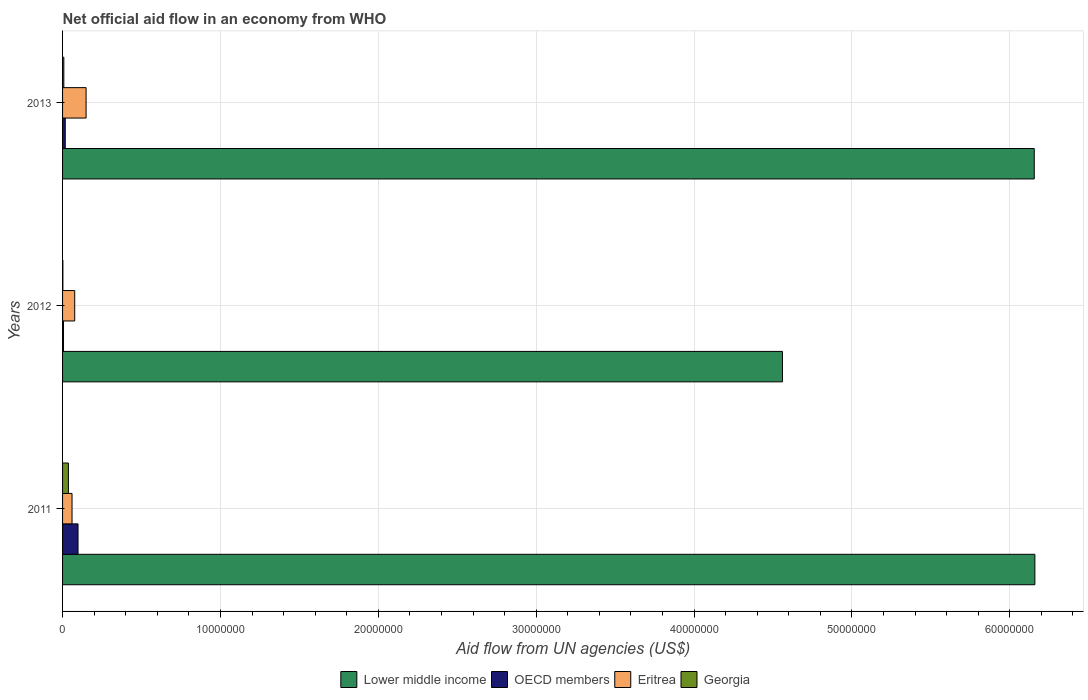How many groups of bars are there?
Give a very brief answer. 3. Are the number of bars per tick equal to the number of legend labels?
Keep it short and to the point. Yes. What is the net official aid flow in Georgia in 2013?
Give a very brief answer. 8.00e+04. Across all years, what is the maximum net official aid flow in Eritrea?
Provide a short and direct response. 1.49e+06. Across all years, what is the minimum net official aid flow in Georgia?
Provide a succinct answer. 2.00e+04. In which year was the net official aid flow in Lower middle income maximum?
Give a very brief answer. 2011. In which year was the net official aid flow in Georgia minimum?
Provide a short and direct response. 2012. What is the total net official aid flow in Georgia in the graph?
Offer a terse response. 4.70e+05. What is the difference between the net official aid flow in OECD members in 2012 and that in 2013?
Provide a short and direct response. -1.10e+05. What is the difference between the net official aid flow in Georgia in 2013 and the net official aid flow in Eritrea in 2012?
Your answer should be very brief. -6.90e+05. What is the average net official aid flow in Lower middle income per year?
Your response must be concise. 5.62e+07. In the year 2011, what is the difference between the net official aid flow in Georgia and net official aid flow in Lower middle income?
Provide a short and direct response. -6.12e+07. In how many years, is the net official aid flow in OECD members greater than 12000000 US$?
Offer a terse response. 0. What is the ratio of the net official aid flow in OECD members in 2012 to that in 2013?
Give a very brief answer. 0.35. What is the difference between the highest and the second highest net official aid flow in Eritrea?
Your answer should be very brief. 7.20e+05. What is the difference between the highest and the lowest net official aid flow in Lower middle income?
Your answer should be compact. 1.60e+07. Is the sum of the net official aid flow in Lower middle income in 2011 and 2012 greater than the maximum net official aid flow in OECD members across all years?
Your answer should be very brief. Yes. Is it the case that in every year, the sum of the net official aid flow in OECD members and net official aid flow in Lower middle income is greater than the sum of net official aid flow in Eritrea and net official aid flow in Georgia?
Your answer should be compact. No. What does the 1st bar from the top in 2012 represents?
Make the answer very short. Georgia. What does the 1st bar from the bottom in 2013 represents?
Offer a terse response. Lower middle income. Is it the case that in every year, the sum of the net official aid flow in OECD members and net official aid flow in Georgia is greater than the net official aid flow in Eritrea?
Offer a very short reply. No. Are all the bars in the graph horizontal?
Your response must be concise. Yes. How many years are there in the graph?
Provide a succinct answer. 3. Does the graph contain any zero values?
Your answer should be compact. No. Where does the legend appear in the graph?
Ensure brevity in your answer.  Bottom center. How many legend labels are there?
Your response must be concise. 4. How are the legend labels stacked?
Make the answer very short. Horizontal. What is the title of the graph?
Your answer should be very brief. Net official aid flow in an economy from WHO. What is the label or title of the X-axis?
Offer a terse response. Aid flow from UN agencies (US$). What is the label or title of the Y-axis?
Offer a terse response. Years. What is the Aid flow from UN agencies (US$) in Lower middle income in 2011?
Your answer should be compact. 6.16e+07. What is the Aid flow from UN agencies (US$) in OECD members in 2011?
Offer a terse response. 9.80e+05. What is the Aid flow from UN agencies (US$) of Georgia in 2011?
Your answer should be very brief. 3.70e+05. What is the Aid flow from UN agencies (US$) in Lower middle income in 2012?
Give a very brief answer. 4.56e+07. What is the Aid flow from UN agencies (US$) in Eritrea in 2012?
Your answer should be very brief. 7.70e+05. What is the Aid flow from UN agencies (US$) of Lower middle income in 2013?
Keep it short and to the point. 6.16e+07. What is the Aid flow from UN agencies (US$) of OECD members in 2013?
Your answer should be compact. 1.70e+05. What is the Aid flow from UN agencies (US$) in Eritrea in 2013?
Your response must be concise. 1.49e+06. Across all years, what is the maximum Aid flow from UN agencies (US$) of Lower middle income?
Your answer should be very brief. 6.16e+07. Across all years, what is the maximum Aid flow from UN agencies (US$) of OECD members?
Your response must be concise. 9.80e+05. Across all years, what is the maximum Aid flow from UN agencies (US$) in Eritrea?
Give a very brief answer. 1.49e+06. Across all years, what is the maximum Aid flow from UN agencies (US$) of Georgia?
Your response must be concise. 3.70e+05. Across all years, what is the minimum Aid flow from UN agencies (US$) of Lower middle income?
Your answer should be compact. 4.56e+07. Across all years, what is the minimum Aid flow from UN agencies (US$) of Eritrea?
Provide a succinct answer. 6.00e+05. Across all years, what is the minimum Aid flow from UN agencies (US$) in Georgia?
Offer a very short reply. 2.00e+04. What is the total Aid flow from UN agencies (US$) in Lower middle income in the graph?
Provide a succinct answer. 1.69e+08. What is the total Aid flow from UN agencies (US$) of OECD members in the graph?
Offer a terse response. 1.21e+06. What is the total Aid flow from UN agencies (US$) in Eritrea in the graph?
Ensure brevity in your answer.  2.86e+06. What is the difference between the Aid flow from UN agencies (US$) in Lower middle income in 2011 and that in 2012?
Your answer should be very brief. 1.60e+07. What is the difference between the Aid flow from UN agencies (US$) of OECD members in 2011 and that in 2012?
Make the answer very short. 9.20e+05. What is the difference between the Aid flow from UN agencies (US$) of Eritrea in 2011 and that in 2012?
Offer a very short reply. -1.70e+05. What is the difference between the Aid flow from UN agencies (US$) of OECD members in 2011 and that in 2013?
Make the answer very short. 8.10e+05. What is the difference between the Aid flow from UN agencies (US$) in Eritrea in 2011 and that in 2013?
Your answer should be compact. -8.90e+05. What is the difference between the Aid flow from UN agencies (US$) in Georgia in 2011 and that in 2013?
Offer a very short reply. 2.90e+05. What is the difference between the Aid flow from UN agencies (US$) of Lower middle income in 2012 and that in 2013?
Make the answer very short. -1.60e+07. What is the difference between the Aid flow from UN agencies (US$) in OECD members in 2012 and that in 2013?
Ensure brevity in your answer.  -1.10e+05. What is the difference between the Aid flow from UN agencies (US$) of Eritrea in 2012 and that in 2013?
Provide a short and direct response. -7.20e+05. What is the difference between the Aid flow from UN agencies (US$) in Lower middle income in 2011 and the Aid flow from UN agencies (US$) in OECD members in 2012?
Offer a very short reply. 6.15e+07. What is the difference between the Aid flow from UN agencies (US$) in Lower middle income in 2011 and the Aid flow from UN agencies (US$) in Eritrea in 2012?
Offer a very short reply. 6.08e+07. What is the difference between the Aid flow from UN agencies (US$) in Lower middle income in 2011 and the Aid flow from UN agencies (US$) in Georgia in 2012?
Your response must be concise. 6.16e+07. What is the difference between the Aid flow from UN agencies (US$) in OECD members in 2011 and the Aid flow from UN agencies (US$) in Georgia in 2012?
Make the answer very short. 9.60e+05. What is the difference between the Aid flow from UN agencies (US$) of Eritrea in 2011 and the Aid flow from UN agencies (US$) of Georgia in 2012?
Provide a short and direct response. 5.80e+05. What is the difference between the Aid flow from UN agencies (US$) of Lower middle income in 2011 and the Aid flow from UN agencies (US$) of OECD members in 2013?
Keep it short and to the point. 6.14e+07. What is the difference between the Aid flow from UN agencies (US$) in Lower middle income in 2011 and the Aid flow from UN agencies (US$) in Eritrea in 2013?
Offer a very short reply. 6.01e+07. What is the difference between the Aid flow from UN agencies (US$) in Lower middle income in 2011 and the Aid flow from UN agencies (US$) in Georgia in 2013?
Provide a succinct answer. 6.15e+07. What is the difference between the Aid flow from UN agencies (US$) in OECD members in 2011 and the Aid flow from UN agencies (US$) in Eritrea in 2013?
Offer a terse response. -5.10e+05. What is the difference between the Aid flow from UN agencies (US$) in Eritrea in 2011 and the Aid flow from UN agencies (US$) in Georgia in 2013?
Offer a terse response. 5.20e+05. What is the difference between the Aid flow from UN agencies (US$) in Lower middle income in 2012 and the Aid flow from UN agencies (US$) in OECD members in 2013?
Offer a terse response. 4.54e+07. What is the difference between the Aid flow from UN agencies (US$) in Lower middle income in 2012 and the Aid flow from UN agencies (US$) in Eritrea in 2013?
Offer a terse response. 4.41e+07. What is the difference between the Aid flow from UN agencies (US$) of Lower middle income in 2012 and the Aid flow from UN agencies (US$) of Georgia in 2013?
Offer a terse response. 4.55e+07. What is the difference between the Aid flow from UN agencies (US$) of OECD members in 2012 and the Aid flow from UN agencies (US$) of Eritrea in 2013?
Make the answer very short. -1.43e+06. What is the difference between the Aid flow from UN agencies (US$) in OECD members in 2012 and the Aid flow from UN agencies (US$) in Georgia in 2013?
Provide a short and direct response. -2.00e+04. What is the difference between the Aid flow from UN agencies (US$) of Eritrea in 2012 and the Aid flow from UN agencies (US$) of Georgia in 2013?
Offer a terse response. 6.90e+05. What is the average Aid flow from UN agencies (US$) in Lower middle income per year?
Provide a succinct answer. 5.62e+07. What is the average Aid flow from UN agencies (US$) in OECD members per year?
Give a very brief answer. 4.03e+05. What is the average Aid flow from UN agencies (US$) of Eritrea per year?
Offer a very short reply. 9.53e+05. What is the average Aid flow from UN agencies (US$) of Georgia per year?
Give a very brief answer. 1.57e+05. In the year 2011, what is the difference between the Aid flow from UN agencies (US$) in Lower middle income and Aid flow from UN agencies (US$) in OECD members?
Give a very brief answer. 6.06e+07. In the year 2011, what is the difference between the Aid flow from UN agencies (US$) of Lower middle income and Aid flow from UN agencies (US$) of Eritrea?
Keep it short and to the point. 6.10e+07. In the year 2011, what is the difference between the Aid flow from UN agencies (US$) of Lower middle income and Aid flow from UN agencies (US$) of Georgia?
Keep it short and to the point. 6.12e+07. In the year 2012, what is the difference between the Aid flow from UN agencies (US$) in Lower middle income and Aid flow from UN agencies (US$) in OECD members?
Ensure brevity in your answer.  4.55e+07. In the year 2012, what is the difference between the Aid flow from UN agencies (US$) in Lower middle income and Aid flow from UN agencies (US$) in Eritrea?
Your response must be concise. 4.48e+07. In the year 2012, what is the difference between the Aid flow from UN agencies (US$) of Lower middle income and Aid flow from UN agencies (US$) of Georgia?
Ensure brevity in your answer.  4.56e+07. In the year 2012, what is the difference between the Aid flow from UN agencies (US$) of OECD members and Aid flow from UN agencies (US$) of Eritrea?
Your response must be concise. -7.10e+05. In the year 2012, what is the difference between the Aid flow from UN agencies (US$) in Eritrea and Aid flow from UN agencies (US$) in Georgia?
Your answer should be very brief. 7.50e+05. In the year 2013, what is the difference between the Aid flow from UN agencies (US$) of Lower middle income and Aid flow from UN agencies (US$) of OECD members?
Your response must be concise. 6.14e+07. In the year 2013, what is the difference between the Aid flow from UN agencies (US$) of Lower middle income and Aid flow from UN agencies (US$) of Eritrea?
Provide a succinct answer. 6.01e+07. In the year 2013, what is the difference between the Aid flow from UN agencies (US$) in Lower middle income and Aid flow from UN agencies (US$) in Georgia?
Make the answer very short. 6.15e+07. In the year 2013, what is the difference between the Aid flow from UN agencies (US$) in OECD members and Aid flow from UN agencies (US$) in Eritrea?
Your answer should be very brief. -1.32e+06. In the year 2013, what is the difference between the Aid flow from UN agencies (US$) of OECD members and Aid flow from UN agencies (US$) of Georgia?
Ensure brevity in your answer.  9.00e+04. In the year 2013, what is the difference between the Aid flow from UN agencies (US$) in Eritrea and Aid flow from UN agencies (US$) in Georgia?
Offer a very short reply. 1.41e+06. What is the ratio of the Aid flow from UN agencies (US$) in Lower middle income in 2011 to that in 2012?
Your answer should be very brief. 1.35. What is the ratio of the Aid flow from UN agencies (US$) in OECD members in 2011 to that in 2012?
Keep it short and to the point. 16.33. What is the ratio of the Aid flow from UN agencies (US$) of Eritrea in 2011 to that in 2012?
Your answer should be compact. 0.78. What is the ratio of the Aid flow from UN agencies (US$) of Lower middle income in 2011 to that in 2013?
Keep it short and to the point. 1. What is the ratio of the Aid flow from UN agencies (US$) of OECD members in 2011 to that in 2013?
Keep it short and to the point. 5.76. What is the ratio of the Aid flow from UN agencies (US$) of Eritrea in 2011 to that in 2013?
Give a very brief answer. 0.4. What is the ratio of the Aid flow from UN agencies (US$) of Georgia in 2011 to that in 2013?
Provide a short and direct response. 4.62. What is the ratio of the Aid flow from UN agencies (US$) in Lower middle income in 2012 to that in 2013?
Your response must be concise. 0.74. What is the ratio of the Aid flow from UN agencies (US$) in OECD members in 2012 to that in 2013?
Your response must be concise. 0.35. What is the ratio of the Aid flow from UN agencies (US$) of Eritrea in 2012 to that in 2013?
Your response must be concise. 0.52. What is the difference between the highest and the second highest Aid flow from UN agencies (US$) in Lower middle income?
Your answer should be compact. 4.00e+04. What is the difference between the highest and the second highest Aid flow from UN agencies (US$) in OECD members?
Offer a terse response. 8.10e+05. What is the difference between the highest and the second highest Aid flow from UN agencies (US$) in Eritrea?
Your answer should be very brief. 7.20e+05. What is the difference between the highest and the second highest Aid flow from UN agencies (US$) in Georgia?
Your response must be concise. 2.90e+05. What is the difference between the highest and the lowest Aid flow from UN agencies (US$) in Lower middle income?
Your answer should be compact. 1.60e+07. What is the difference between the highest and the lowest Aid flow from UN agencies (US$) in OECD members?
Your answer should be very brief. 9.20e+05. What is the difference between the highest and the lowest Aid flow from UN agencies (US$) in Eritrea?
Give a very brief answer. 8.90e+05. What is the difference between the highest and the lowest Aid flow from UN agencies (US$) in Georgia?
Your answer should be very brief. 3.50e+05. 